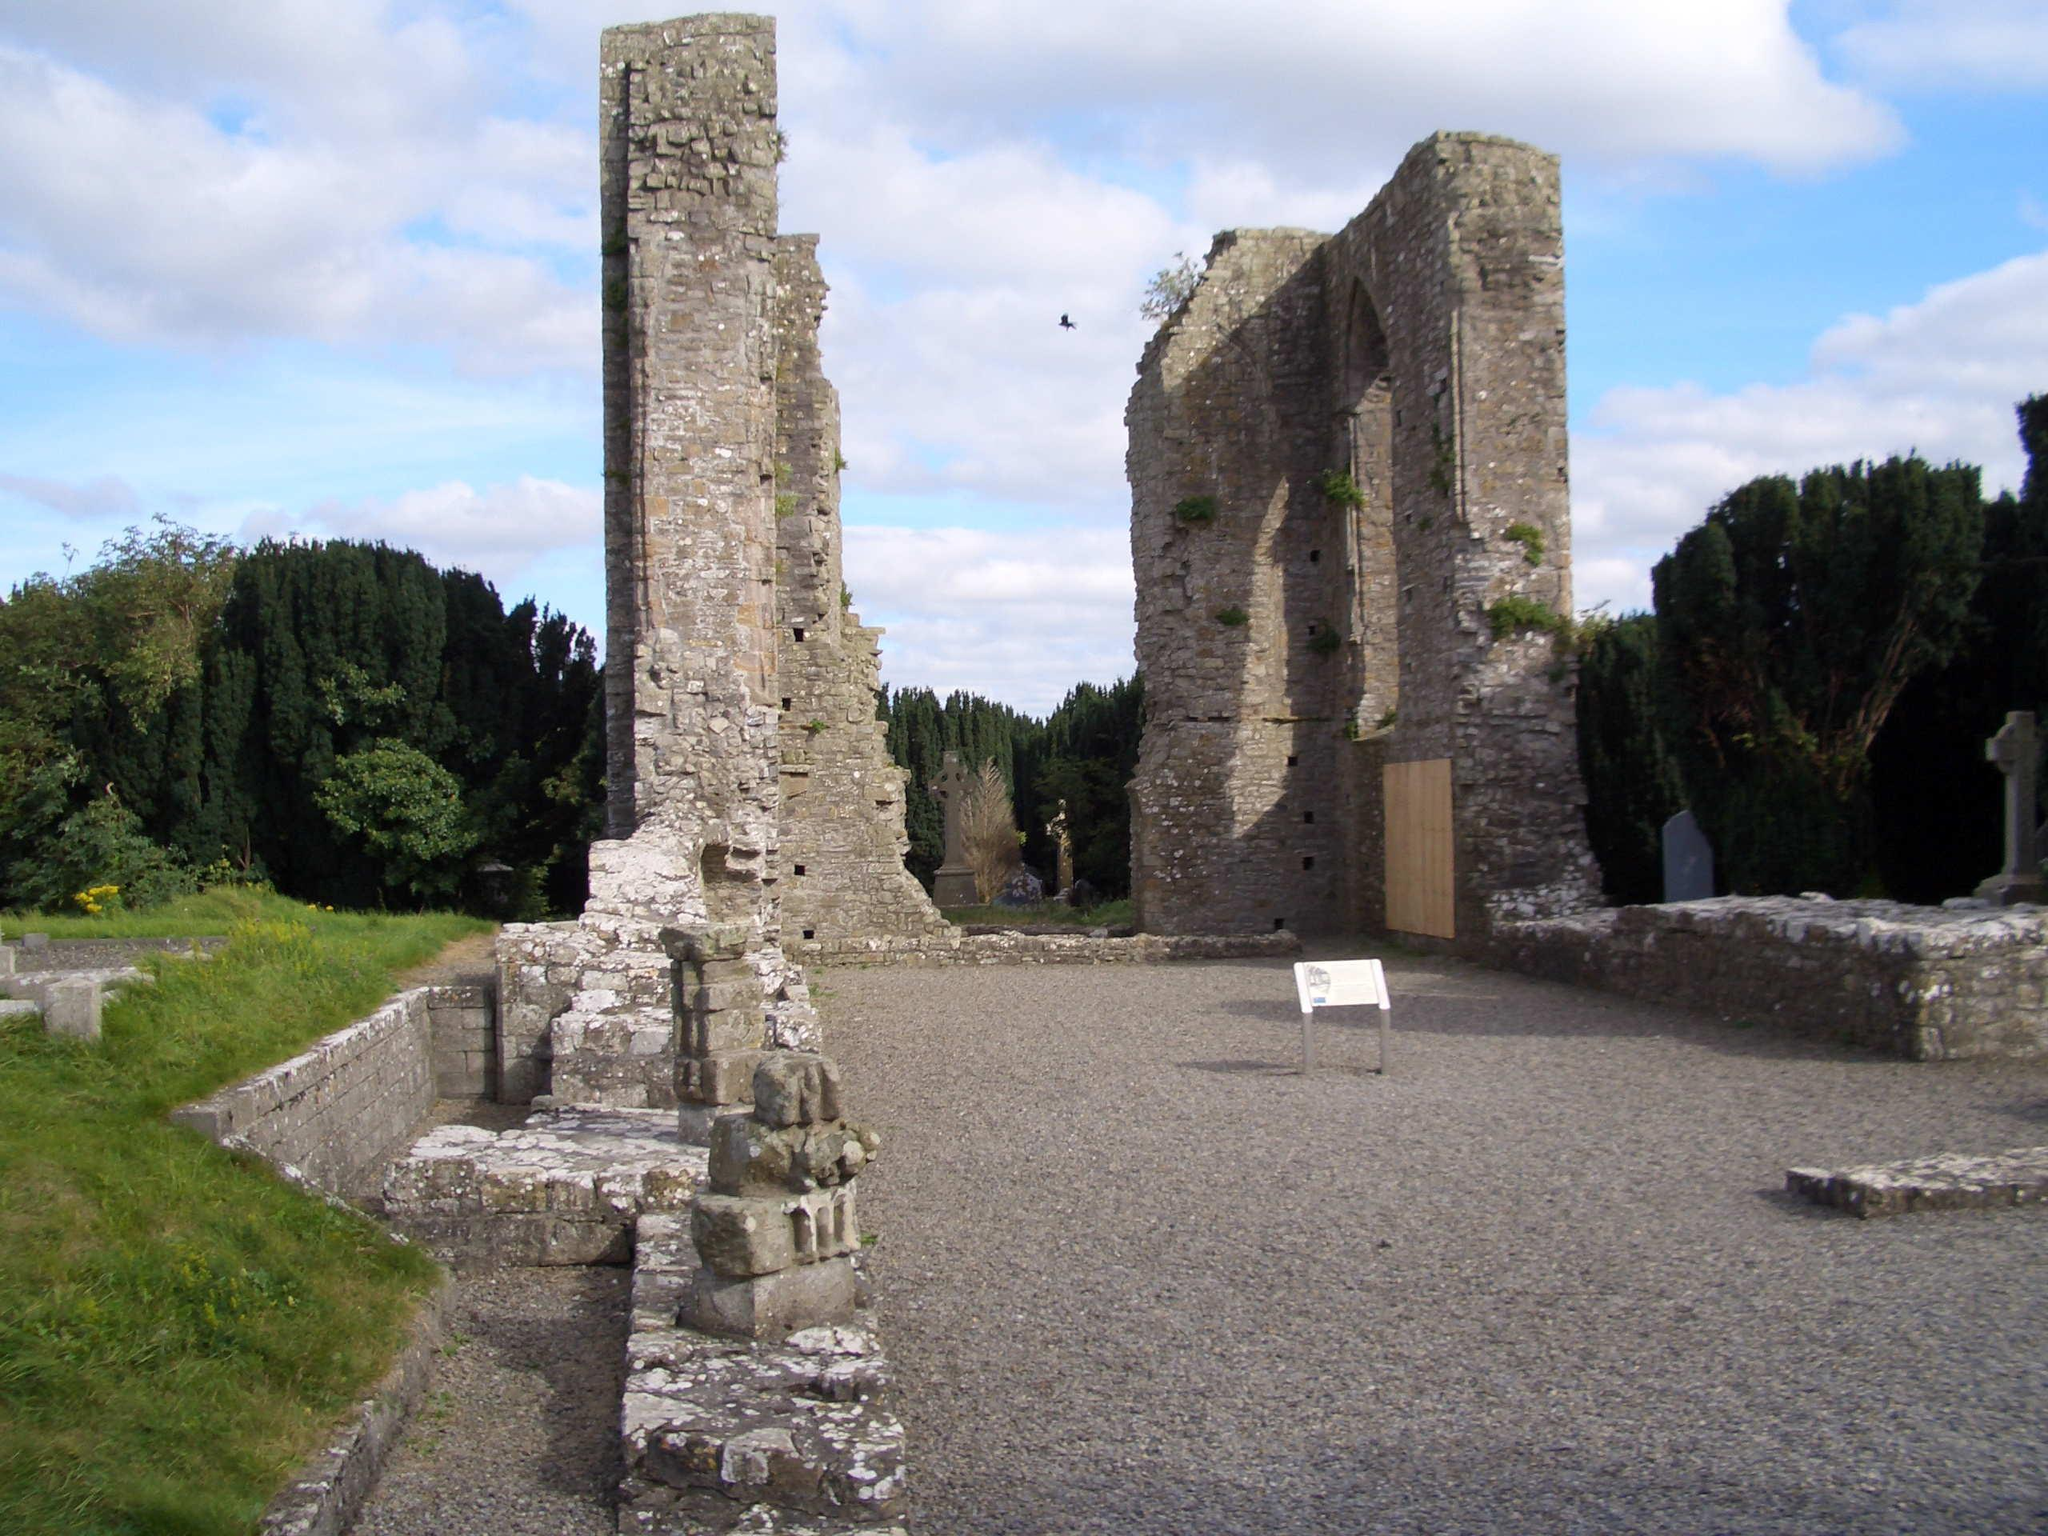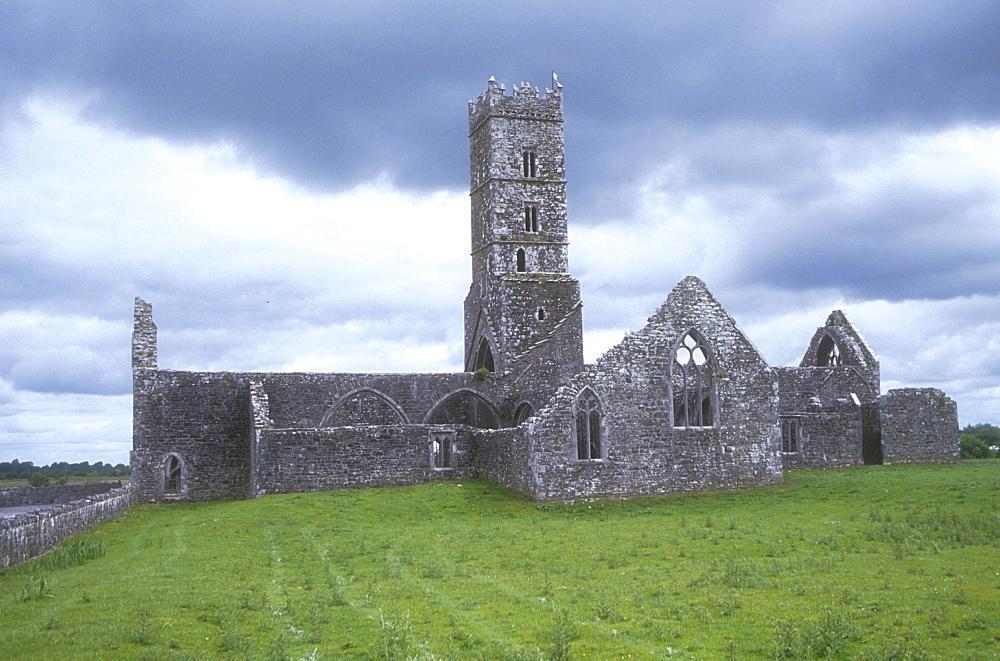The first image is the image on the left, the second image is the image on the right. Examine the images to the left and right. Is the description "The nearest end wall of ancient stone church ruins rises to a triangular point with a large window opening placed directly under the point." accurate? Answer yes or no. Yes. 